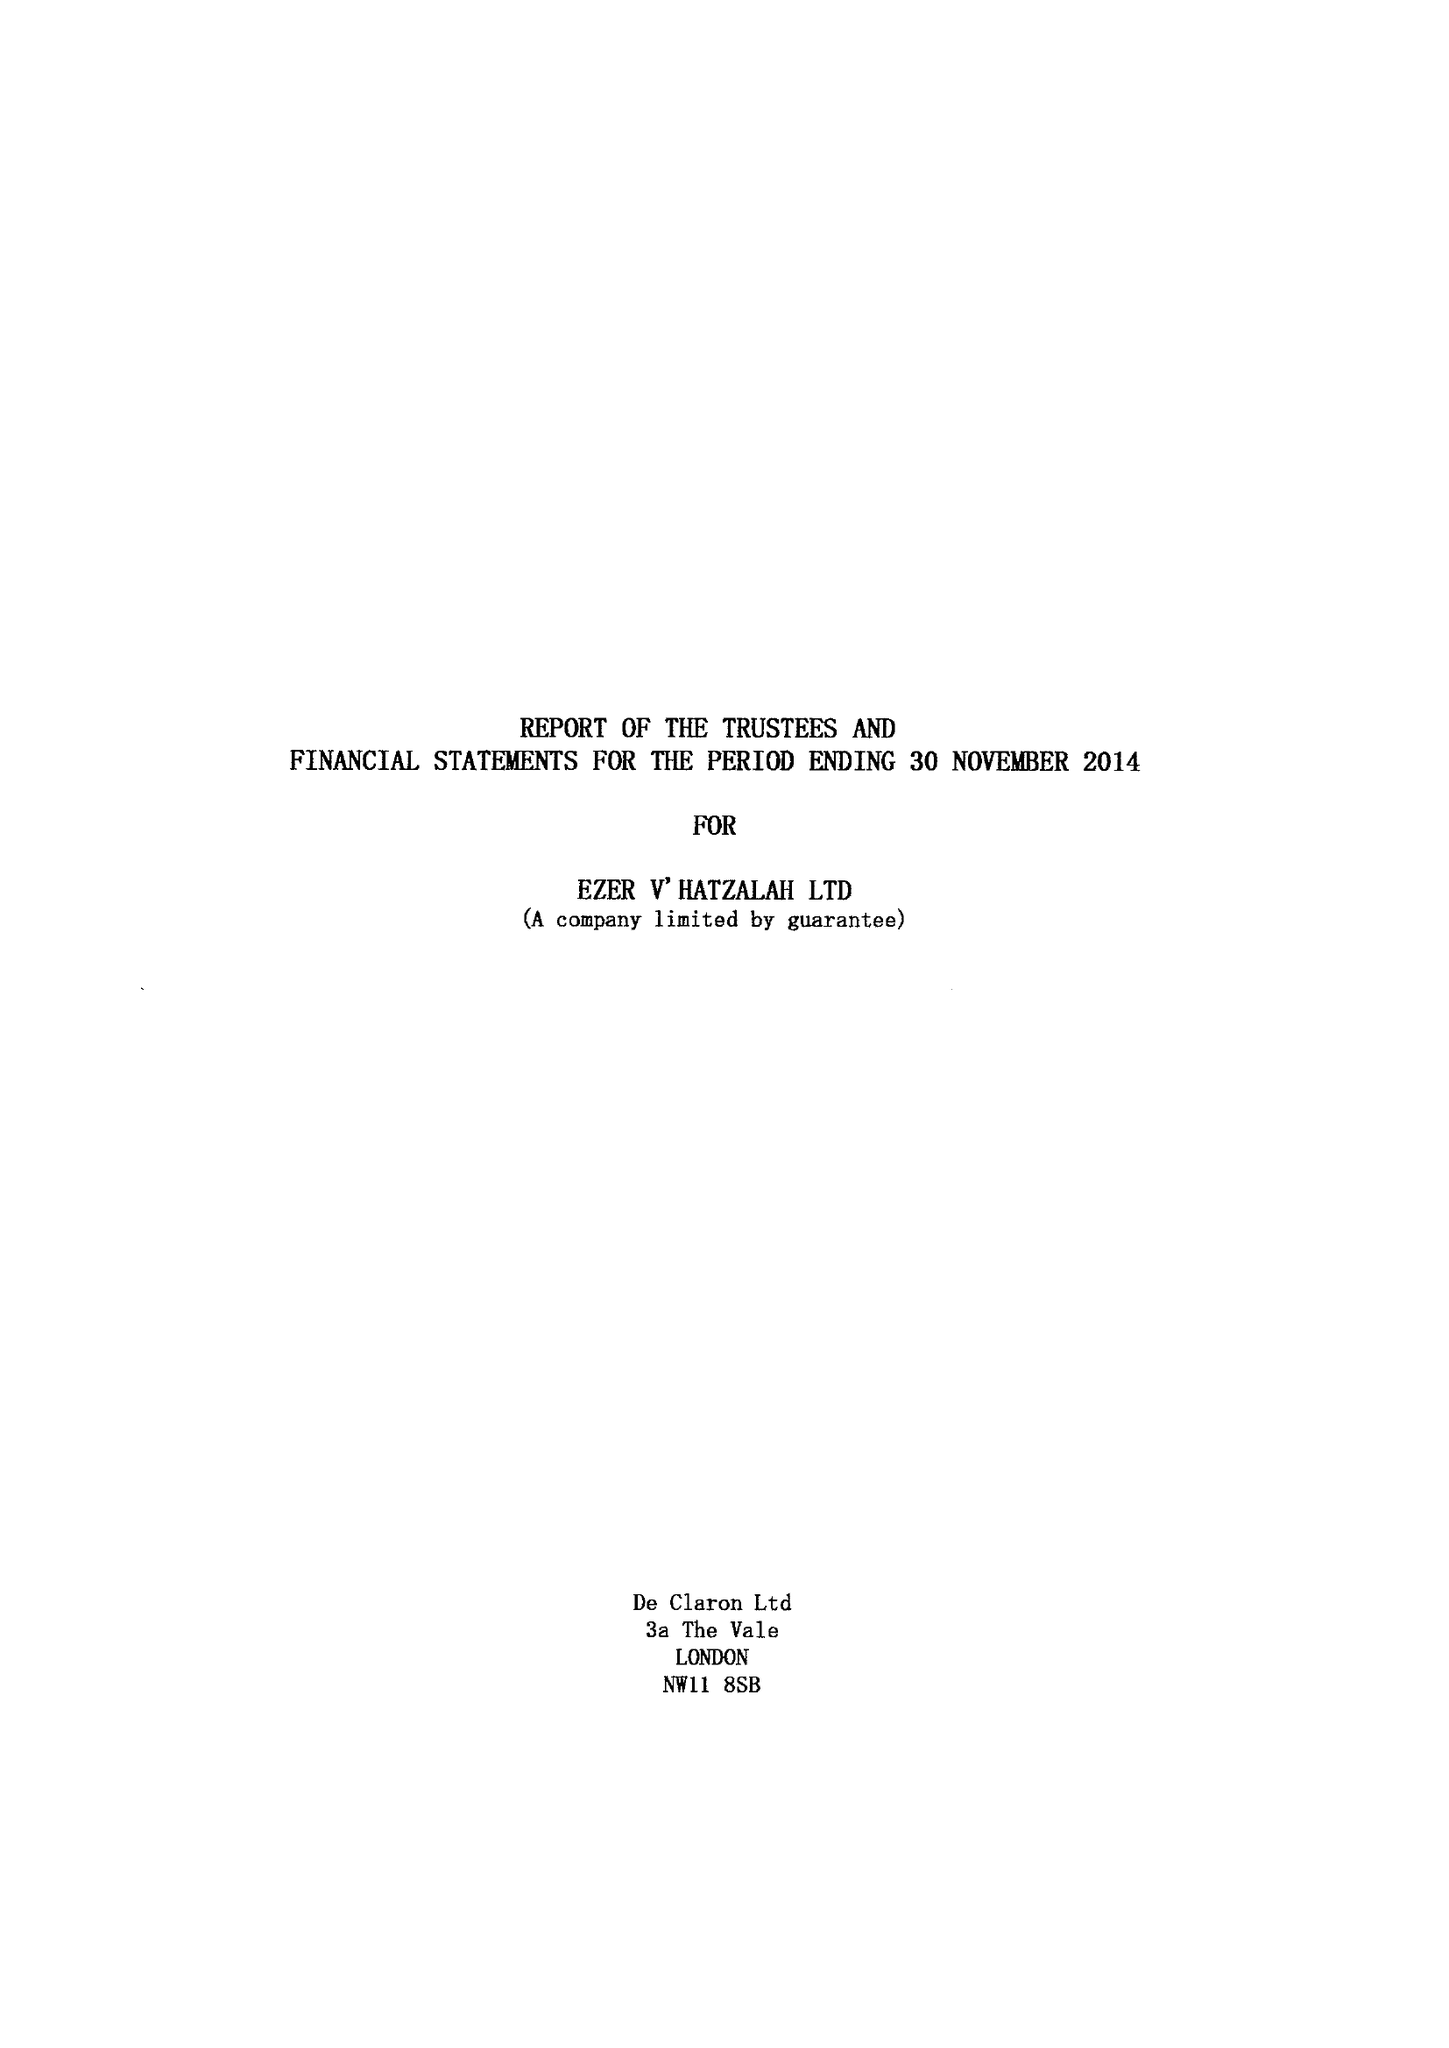What is the value for the income_annually_in_british_pounds?
Answer the question using a single word or phrase. 8224926.00 